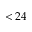<formula> <loc_0><loc_0><loc_500><loc_500>< 2 4</formula> 